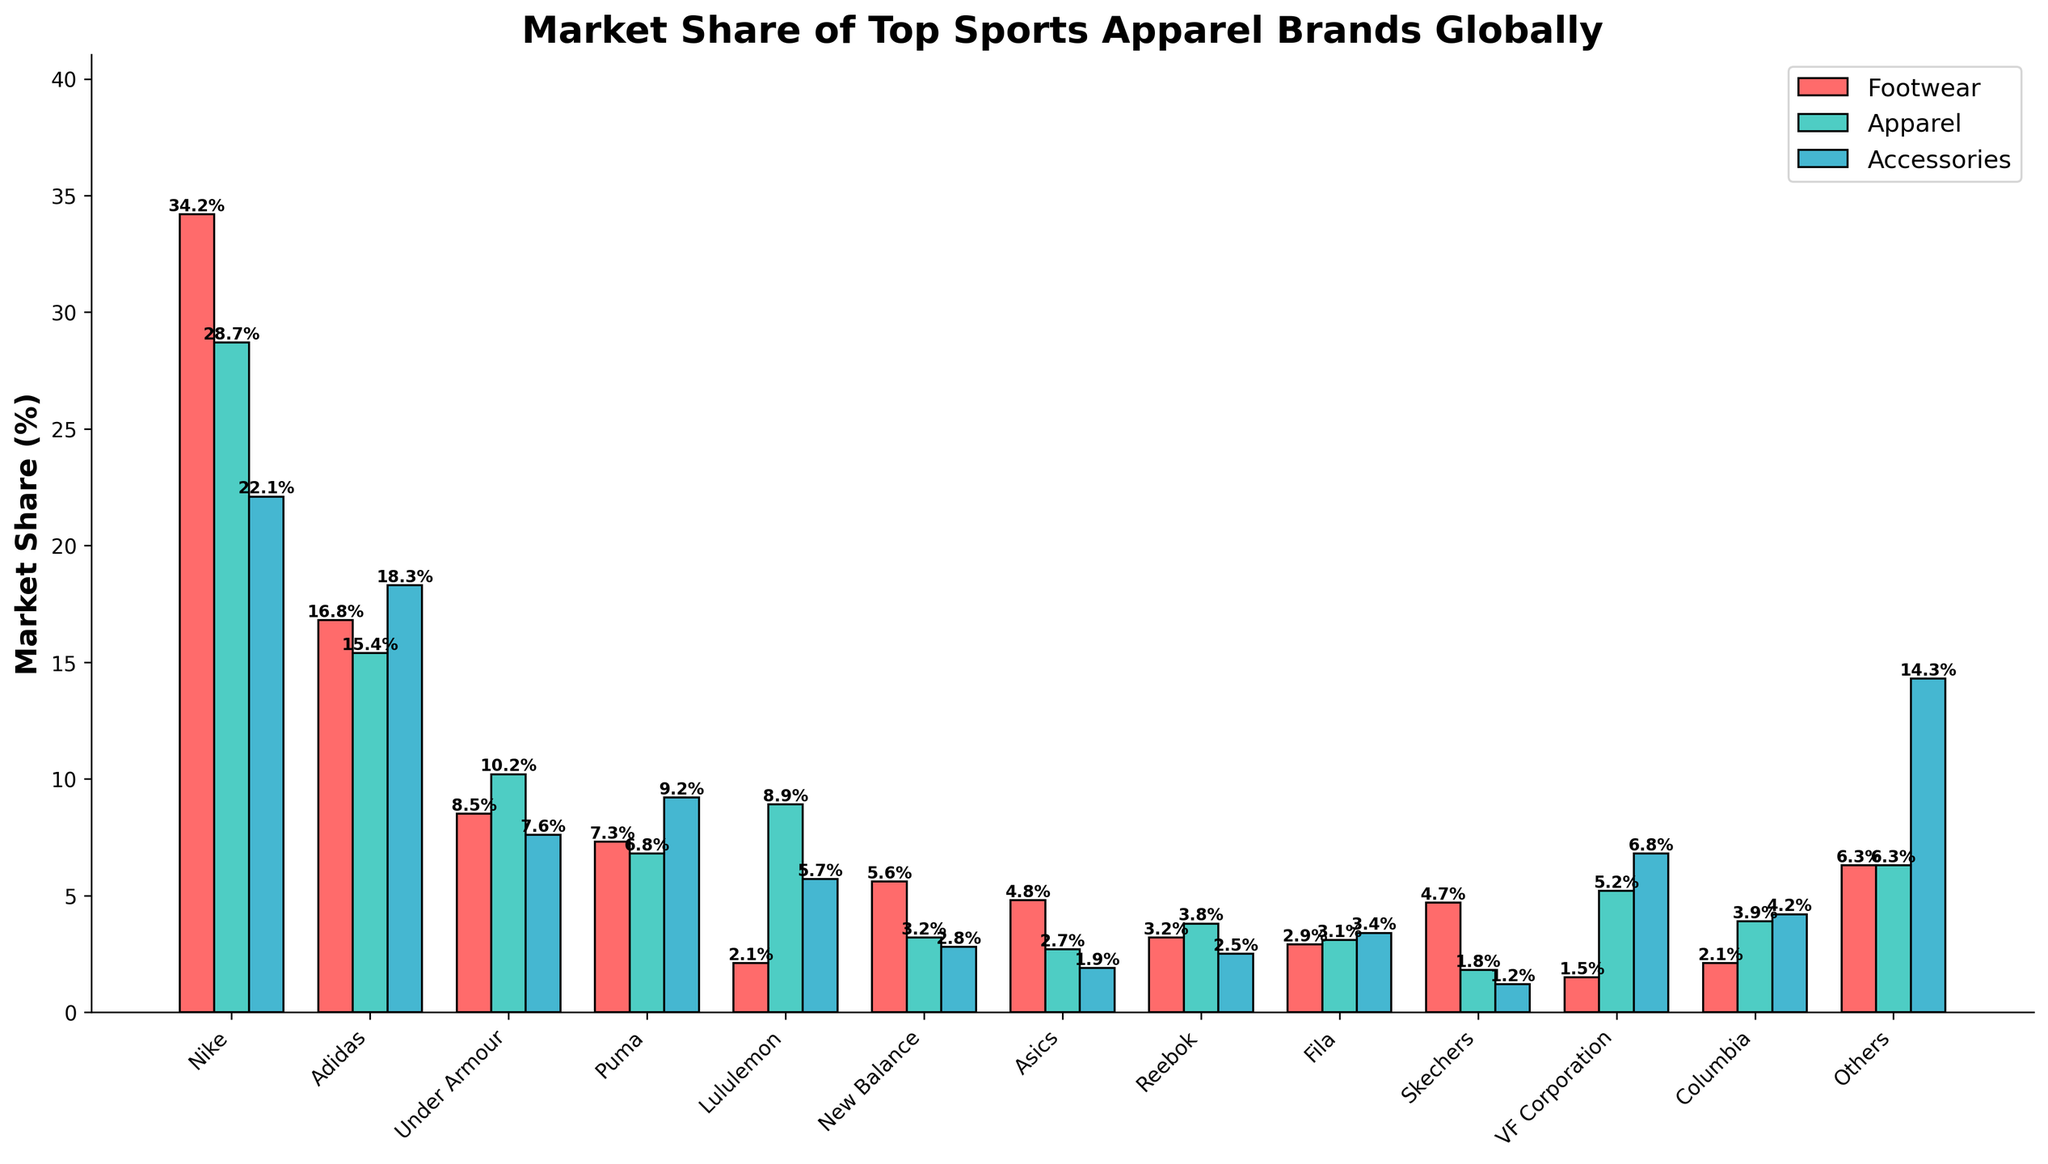Which brand has the highest market share in the 'Footwear' category? From the figure, the brand with the tallest red bar in the 'Footwear' category is Nike.
Answer: Nike What is the combined market share of 'Accessories' for Adidas and Puma? The market share in 'Accessories' for Adidas is 18.3% and for Puma is 9.2%. Adding these together: 18.3% + 9.2% = 27.5%.
Answer: 27.5% Which product category does Under Armour have the highest market share in? Under Armour has the highest bar in green (Apparel) category with a value of 10.2%.
Answer: Apparel How much greater is Nike's 'Apparel' market share compared to Under Armour's 'Apparel' market share? Nike’s market share in 'Apparel' is 28.7% while Under Armour’s is 10.2%. The difference is 28.7% - 10.2% = 18.5%.
Answer: 18.5% Which brand has the least market share in the 'Accessories' category? The shortest blue bar in the 'Accessories' category belongs to Skechers with a value of 1.2%.
Answer: Skechers What is the average market share of 'Apparel' for Nike, Adidas, and Under Armour? Sum the 'Apparel' market shares for Nike (28.7%), Adidas (15.4%), and Under Armour (10.2%): 28.7% + 15.4% + 10.2% = 54.3%. Then divide by 3 to find the average: 54.3% / 3 = 18.1%.
Answer: 18.1% Which category has the most evenly distributed market share among the brands? Visually comparing the height of the bars: 'Accessories' (blue bars) seem to be more evenly distributed compared to 'Footwear' (red) and 'Apparel' (green) where Nike dominates.
Answer: Accessories What is the total market share of 'Footwear' for all brands combined? Sum up the market shares of 'Footwear' for all brands: Nike (34.2%), Adidas (16.8%), Under Armour (8.5%), Puma (7.3%), Lululemon (2.1%), New Balance (5.6%), Asics (4.8%), Reebok (3.2%), Fila (2.9%), Skechers (4.7%), VF Corporation (1.5%), Columbia (2.1%), Others (6.3%). Total: 34.2% + 16.8% + 8.5% + 7.3% + 2.1% + 5.6% + 4.8% + 3.2% + 2.9% + 4.7% + 1.5% + 2.1% + 6.3% = 100%.
Answer: 100% How does the market share of 'Apparel' for Columbia compare to Reebok? In the 'Apparel' category, Columbia’s market share is 3.9%, while Reebok’s market share is 3.8%. So, Columbia has a slightly higher market share by 0.1%.
Answer: Columbia 